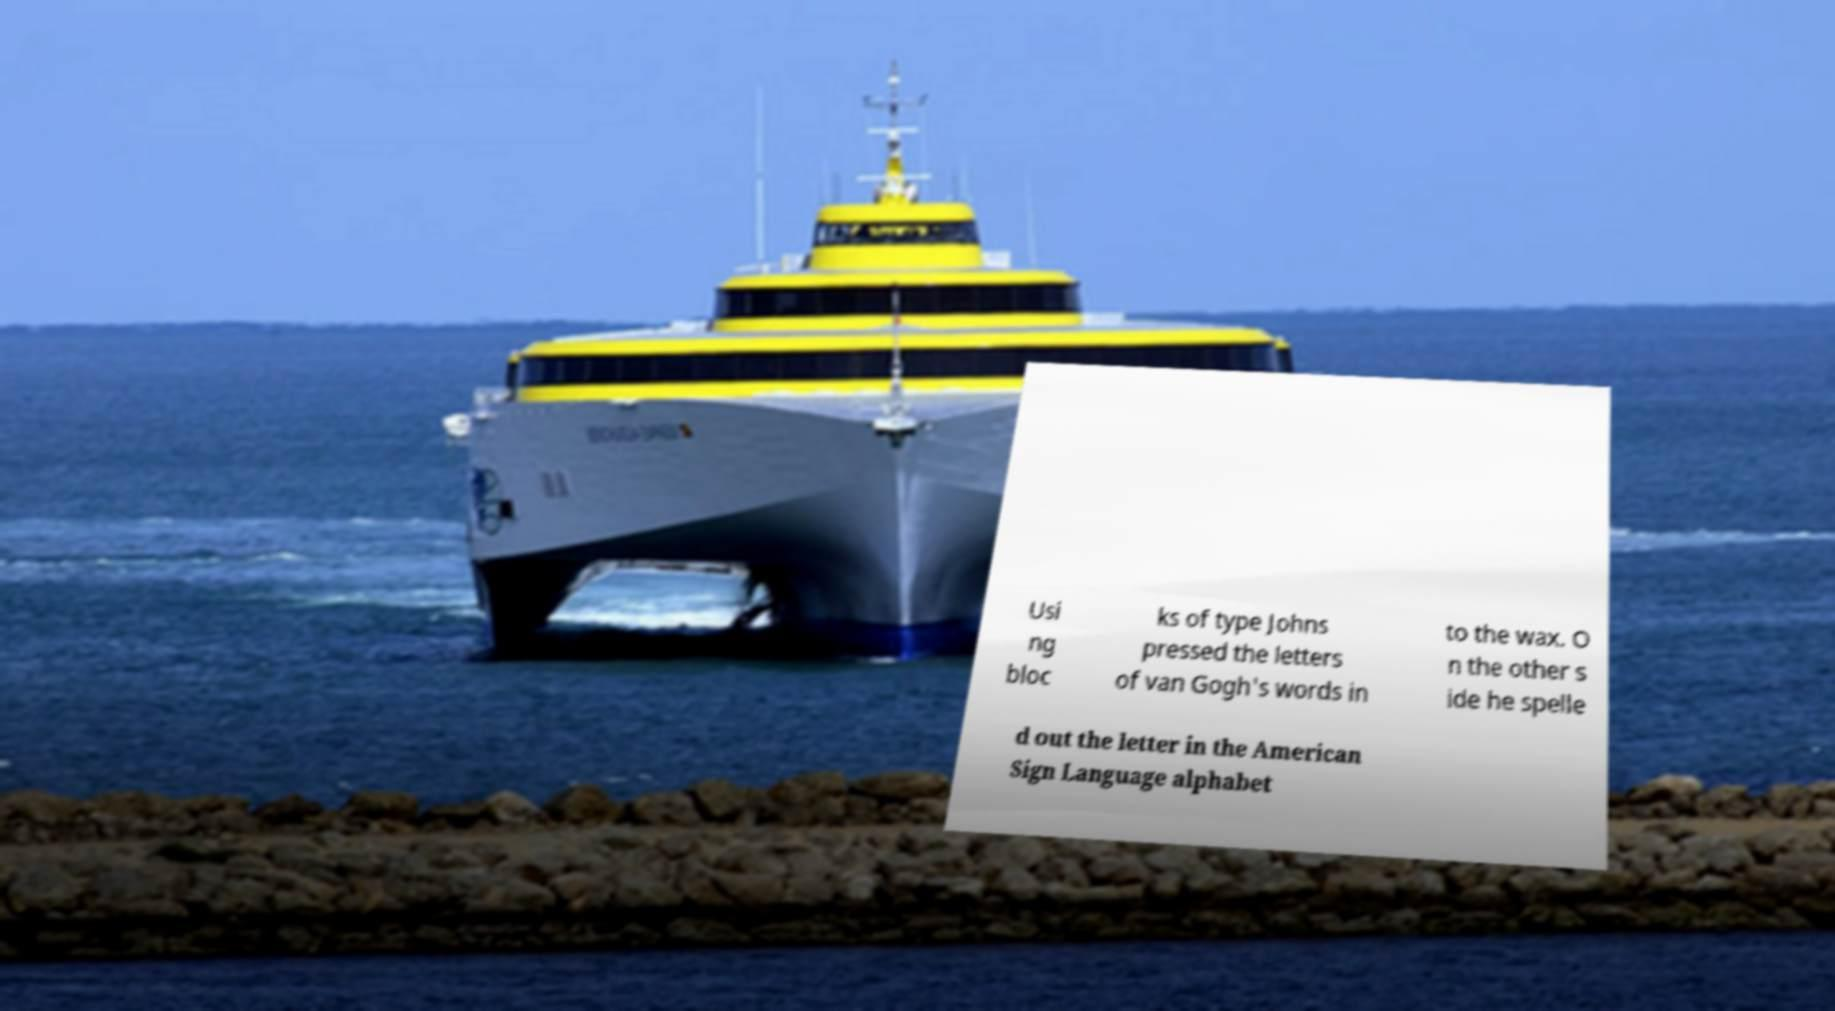Please identify and transcribe the text found in this image. Usi ng bloc ks of type Johns pressed the letters of van Gogh's words in to the wax. O n the other s ide he spelle d out the letter in the American Sign Language alphabet 